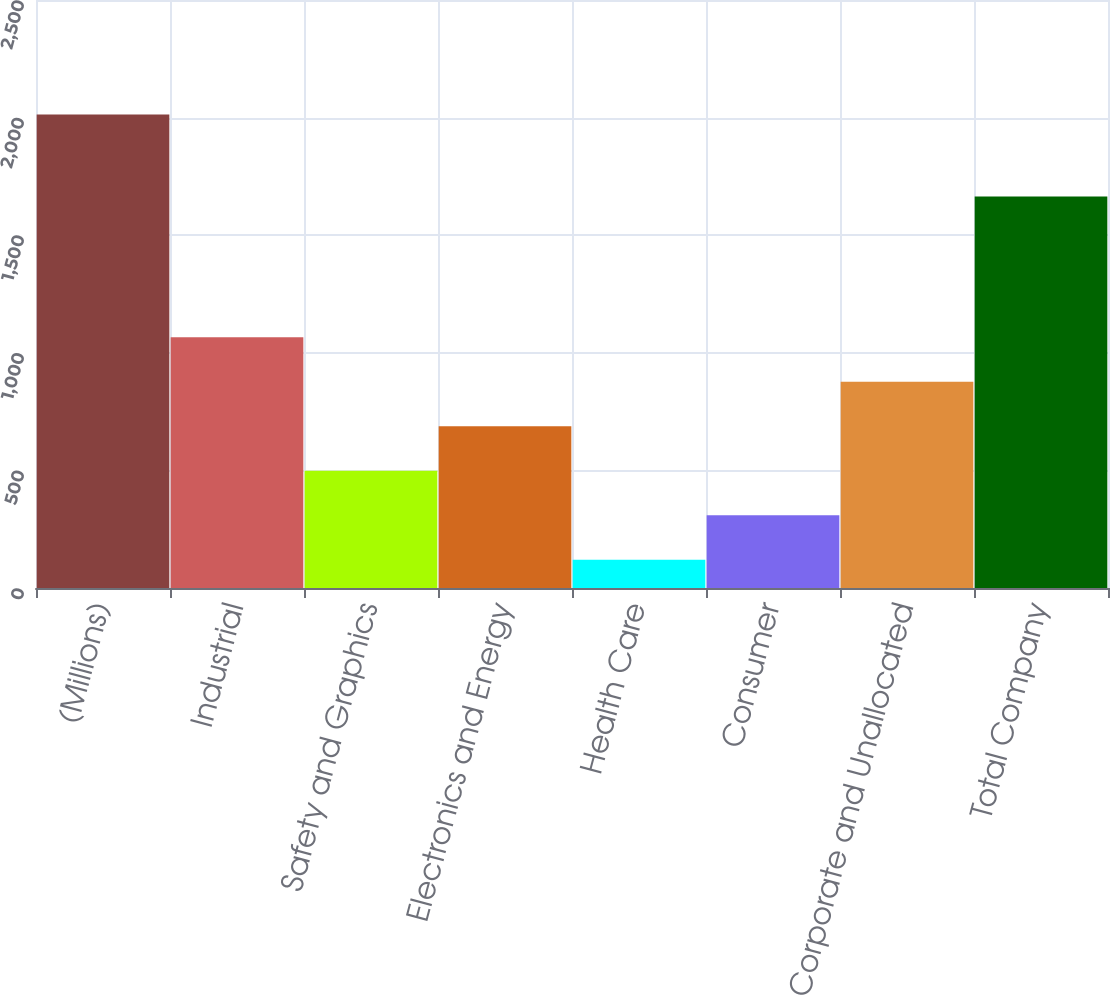Convert chart to OTSL. <chart><loc_0><loc_0><loc_500><loc_500><bar_chart><fcel>(Millions)<fcel>Industrial<fcel>Safety and Graphics<fcel>Electronics and Energy<fcel>Health Care<fcel>Consumer<fcel>Corporate and Unallocated<fcel>Total Company<nl><fcel>2013<fcel>1066.5<fcel>498.6<fcel>687.9<fcel>120<fcel>309.3<fcel>877.2<fcel>1665<nl></chart> 